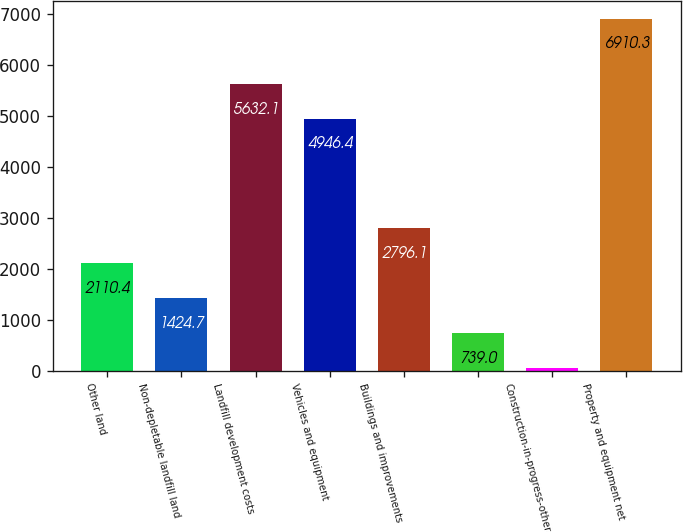Convert chart to OTSL. <chart><loc_0><loc_0><loc_500><loc_500><bar_chart><fcel>Other land<fcel>Non-depletable landfill land<fcel>Landfill development costs<fcel>Vehicles and equipment<fcel>Buildings and improvements<fcel>Unnamed: 5<fcel>Construction-in-progress-other<fcel>Property and equipment net<nl><fcel>2110.4<fcel>1424.7<fcel>5632.1<fcel>4946.4<fcel>2796.1<fcel>739<fcel>53.3<fcel>6910.3<nl></chart> 